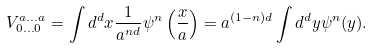<formula> <loc_0><loc_0><loc_500><loc_500>V _ { 0 \dots 0 } ^ { a \dots a } = \int d ^ { d } x \frac { 1 } { a ^ { n d } } \psi ^ { n } \left ( \frac { x } { a } \right ) = a ^ { ( 1 - n ) d } \int d ^ { d } y \psi ^ { n } ( y ) .</formula> 